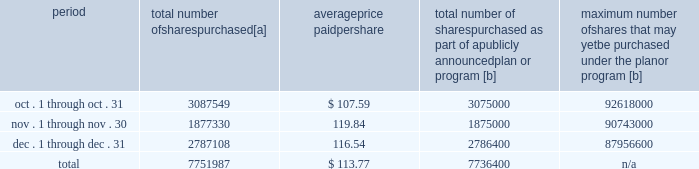Five-year performance comparison 2013 the following graph provides an indicator of cumulative total shareholder returns for the corporation as compared to the peer group index ( described above ) , the dj trans , and the s&p 500 .
The graph assumes that $ 100 was invested in the common stock of union pacific corporation and each index on december 31 , 2009 and that all dividends were reinvested .
The information below is historical in nature and is not necessarily indicative of future performance .
Purchases of equity securities 2013 during 2014 , we repurchased 33035204 shares of our common stock at an average price of $ 100.24 .
The table presents common stock repurchases during each month for the fourth quarter of 2014 : period total number of shares purchased [a] average price paid per share total number of shares purchased as part of a publicly announced plan or program [b] maximum number of shares that may yet be purchased under the plan or program [b] .
[a] total number of shares purchased during the quarter includes approximately 15587 shares delivered or attested to upc by employees to pay stock option exercise prices , satisfy excess tax withholding obligations for stock option exercises or vesting of retention units , and pay withholding obligations for vesting of retention shares .
[b] effective january 1 , 2014 , our board of directors authorized the repurchase of up to 120 million shares of our common stock by december 31 , 2017 .
These repurchases may be made on the open market or through other transactions .
Our management has sole discretion with respect to determining the timing and amount of these transactions. .
What percentage of total number of shares purchased were purchased in november? 
Computations: (1877330 / 7751987)
Answer: 0.24217. 